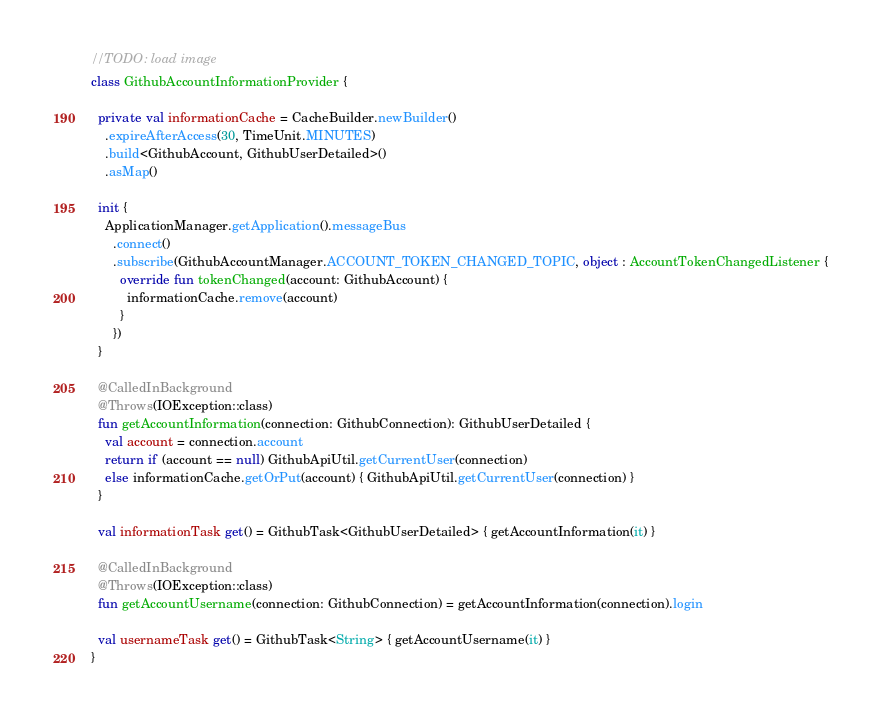<code> <loc_0><loc_0><loc_500><loc_500><_Kotlin_>//TODO: load image
class GithubAccountInformationProvider {

  private val informationCache = CacheBuilder.newBuilder()
    .expireAfterAccess(30, TimeUnit.MINUTES)
    .build<GithubAccount, GithubUserDetailed>()
    .asMap()

  init {
    ApplicationManager.getApplication().messageBus
      .connect()
      .subscribe(GithubAccountManager.ACCOUNT_TOKEN_CHANGED_TOPIC, object : AccountTokenChangedListener {
        override fun tokenChanged(account: GithubAccount) {
          informationCache.remove(account)
        }
      })
  }

  @CalledInBackground
  @Throws(IOException::class)
  fun getAccountInformation(connection: GithubConnection): GithubUserDetailed {
    val account = connection.account
    return if (account == null) GithubApiUtil.getCurrentUser(connection)
    else informationCache.getOrPut(account) { GithubApiUtil.getCurrentUser(connection) }
  }

  val informationTask get() = GithubTask<GithubUserDetailed> { getAccountInformation(it) }

  @CalledInBackground
  @Throws(IOException::class)
  fun getAccountUsername(connection: GithubConnection) = getAccountInformation(connection).login

  val usernameTask get() = GithubTask<String> { getAccountUsername(it) }
}</code> 